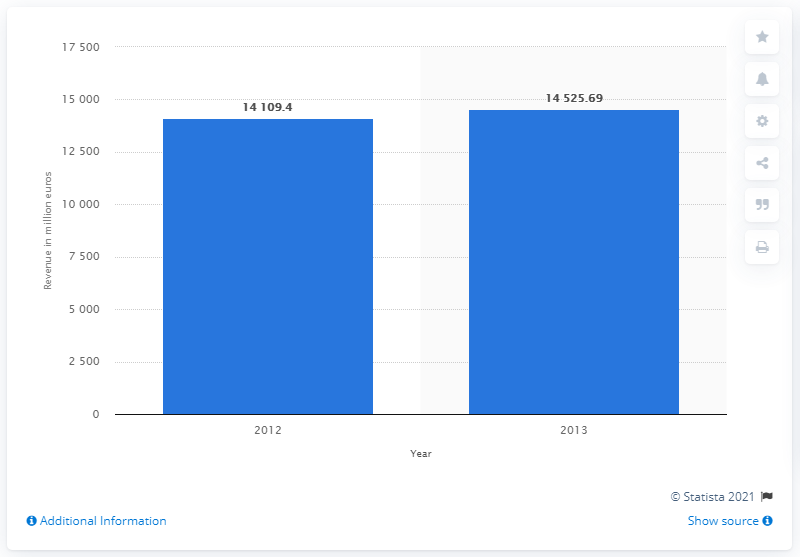Indicate a few pertinent items in this graphic. The revenue of Birkenstock & Co. between 2012 and 2013 was 14,109.4. Birkenstock & Co. generated a revenue of 145,256.90 between 2012 and 2013. 